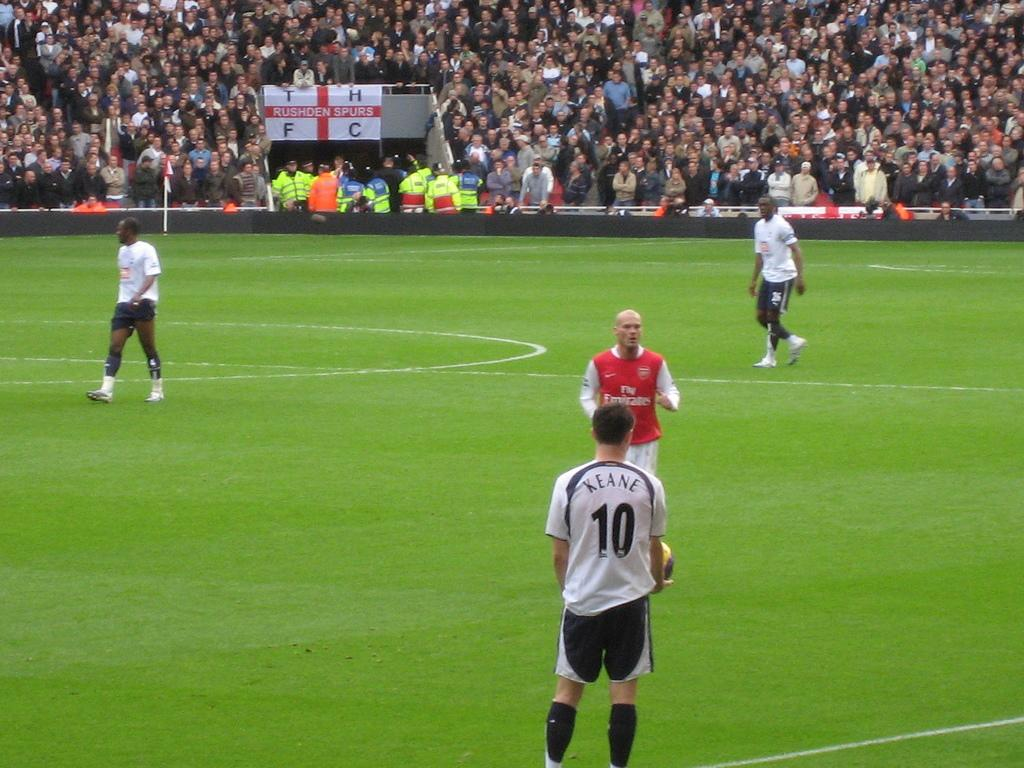What is happening on the ground in the image? There are people on the ground in the image. Can you describe the people in the backside of the image? There is a group of people on the backside of the image. What is the purpose of the fence in the image? The fence in the image serves as a barrier or boundary. What is attached to the pole in the image? There is a flag on a pole in the image. What can be read on the banner in the image? There is a banner with text in the image. What type of twig is being used as a prop in the image? There is no twig present in the image. What time of day is depicted in the image? The time of day cannot be determined from the image alone, as there is no specific indication of the time. 